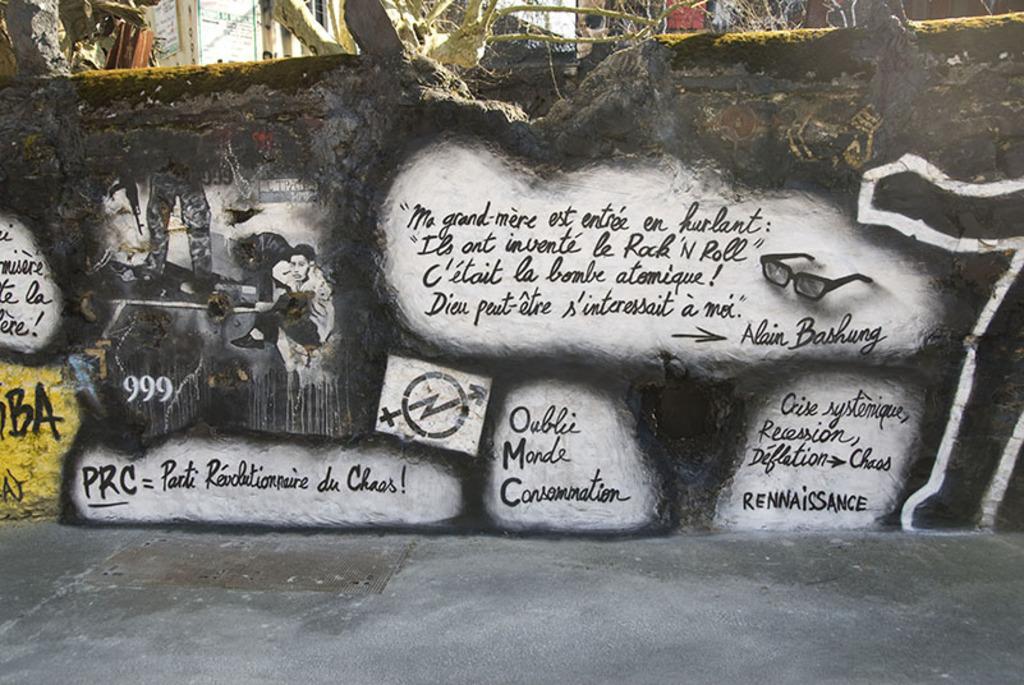Can you describe this image briefly? In this image I can see some text written on the wall. In the background, I can see the buildings. 